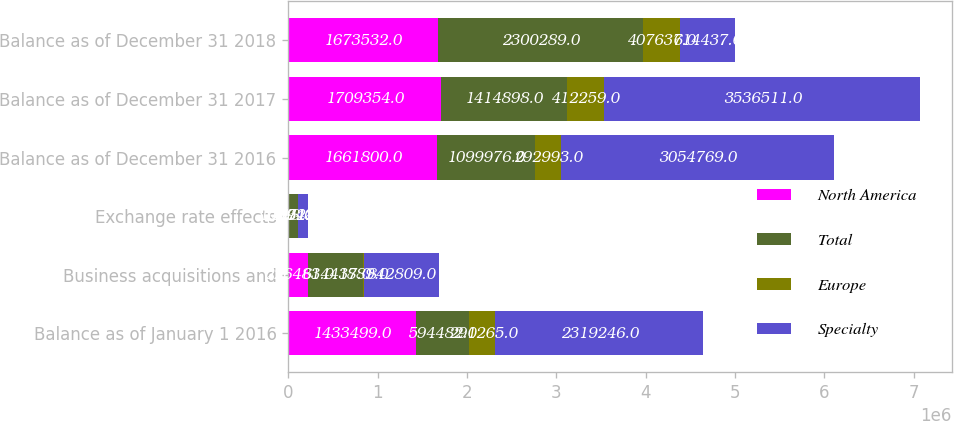Convert chart. <chart><loc_0><loc_0><loc_500><loc_500><stacked_bar_chart><ecel><fcel>Balance as of January 1 2016<fcel>Business acquisitions and<fcel>Exchange rate effects<fcel>Balance as of December 31 2016<fcel>Balance as of December 31 2017<fcel>Balance as of December 31 2018<nl><fcel>North America<fcel>1.4335e+06<fcel>226483<fcel>1818<fcel>1.6618e+06<fcel>1.70935e+06<fcel>1.67353e+06<nl><fcel>Total<fcel>594482<fcel>614437<fcel>108943<fcel>1.09998e+06<fcel>1.4149e+06<fcel>2.30029e+06<nl><fcel>Europe<fcel>291265<fcel>1889<fcel>161<fcel>292993<fcel>412259<fcel>407637<nl><fcel>Specialty<fcel>2.31925e+06<fcel>842809<fcel>107286<fcel>3.05477e+06<fcel>3.53651e+06<fcel>614437<nl></chart> 